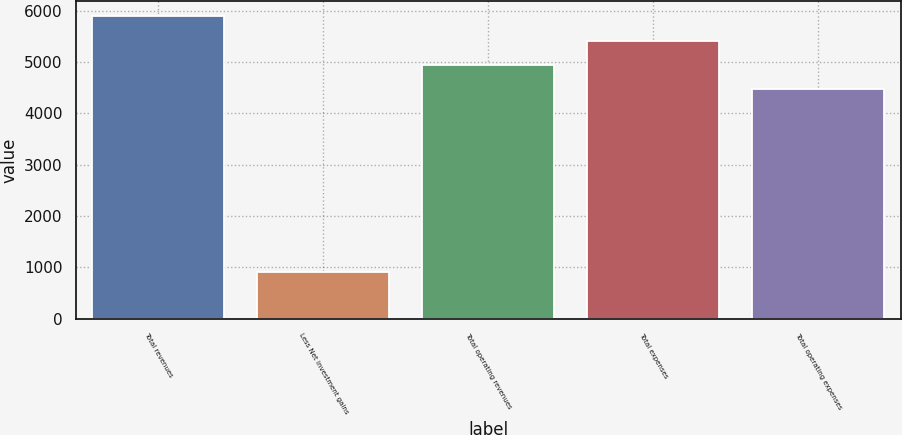<chart> <loc_0><loc_0><loc_500><loc_500><bar_chart><fcel>Total revenues<fcel>Less Net investment gains<fcel>Total operating revenues<fcel>Total expenses<fcel>Total operating expenses<nl><fcel>5890.7<fcel>901<fcel>4944.9<fcel>5417.8<fcel>4472<nl></chart> 